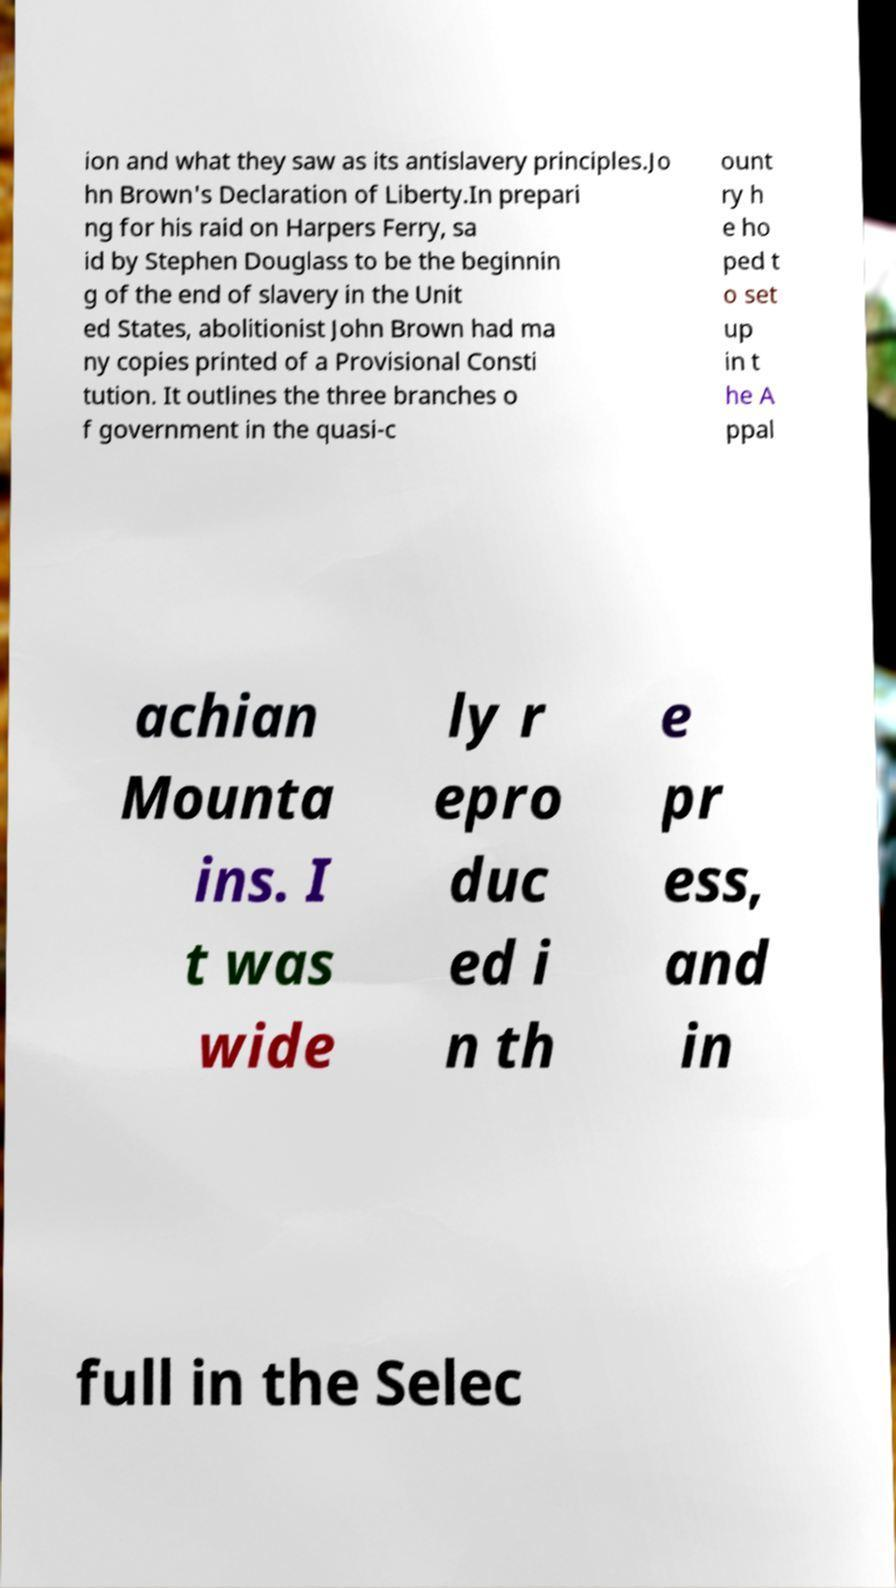Please read and relay the text visible in this image. What does it say? ion and what they saw as its antislavery principles.Jo hn Brown's Declaration of Liberty.In prepari ng for his raid on Harpers Ferry, sa id by Stephen Douglass to be the beginnin g of the end of slavery in the Unit ed States, abolitionist John Brown had ma ny copies printed of a Provisional Consti tution. It outlines the three branches o f government in the quasi-c ount ry h e ho ped t o set up in t he A ppal achian Mounta ins. I t was wide ly r epro duc ed i n th e pr ess, and in full in the Selec 